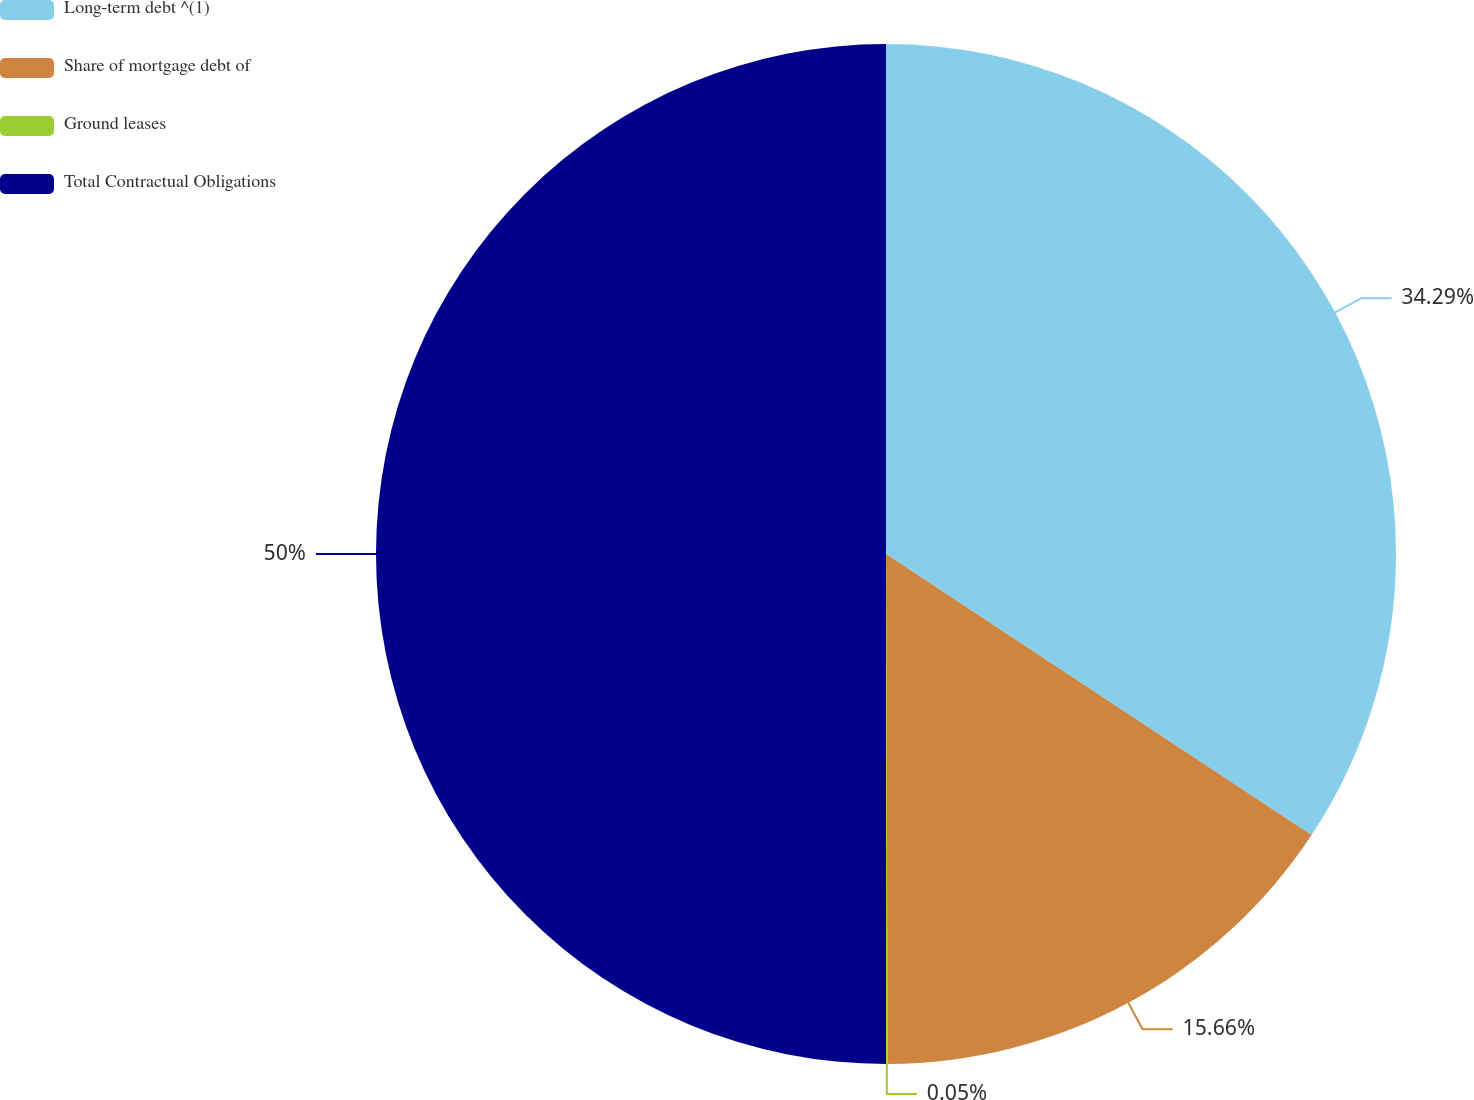Convert chart to OTSL. <chart><loc_0><loc_0><loc_500><loc_500><pie_chart><fcel>Long-term debt ^(1)<fcel>Share of mortgage debt of<fcel>Ground leases<fcel>Total Contractual Obligations<nl><fcel>34.29%<fcel>15.66%<fcel>0.05%<fcel>50.0%<nl></chart> 